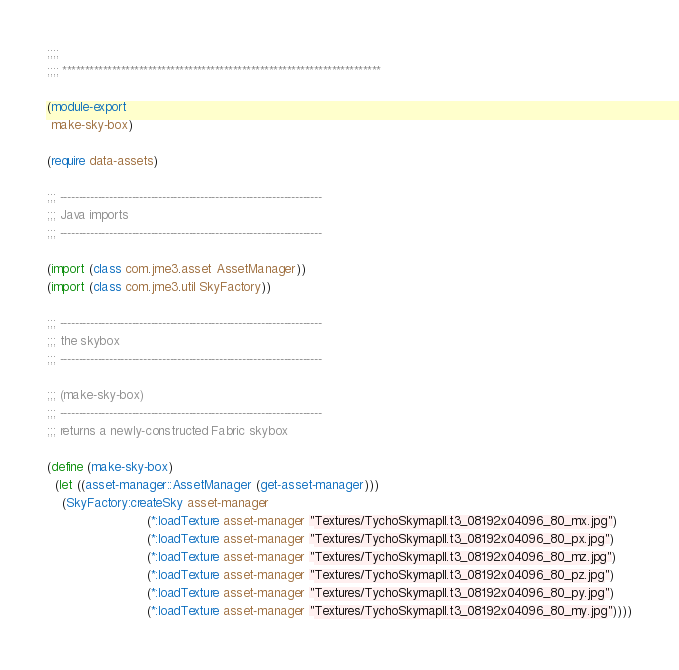Convert code to text. <code><loc_0><loc_0><loc_500><loc_500><_Scheme_>;;;;
;;;; ***********************************************************************

(module-export
 make-sky-box)

(require data-assets)

;;; ---------------------------------------------------------------------
;;; Java imports
;;; ---------------------------------------------------------------------

(import (class com.jme3.asset AssetManager))
(import (class com.jme3.util SkyFactory))

;;; ---------------------------------------------------------------------
;;; the skybox
;;; ---------------------------------------------------------------------

;;; (make-sky-box)
;;; ---------------------------------------------------------------------
;;; returns a newly-constructed Fabric skybox

(define (make-sky-box)
  (let ((asset-manager::AssetManager (get-asset-manager)))
    (SkyFactory:createSky asset-manager 
                          (*:loadTexture asset-manager "Textures/TychoSkymapII.t3_08192x04096_80_mx.jpg")
                          (*:loadTexture asset-manager "Textures/TychoSkymapII.t3_08192x04096_80_px.jpg")
                          (*:loadTexture asset-manager "Textures/TychoSkymapII.t3_08192x04096_80_mz.jpg")
                          (*:loadTexture asset-manager "Textures/TychoSkymapII.t3_08192x04096_80_pz.jpg")
                          (*:loadTexture asset-manager "Textures/TychoSkymapII.t3_08192x04096_80_py.jpg")
                          (*:loadTexture asset-manager "Textures/TychoSkymapII.t3_08192x04096_80_my.jpg"))))
</code> 